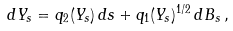<formula> <loc_0><loc_0><loc_500><loc_500>d Y _ { s } = q _ { 2 } ( Y _ { s } ) \, d s + q _ { 1 } ( Y _ { s } ) ^ { 1 / 2 } \, d B _ { s } \, ,</formula> 